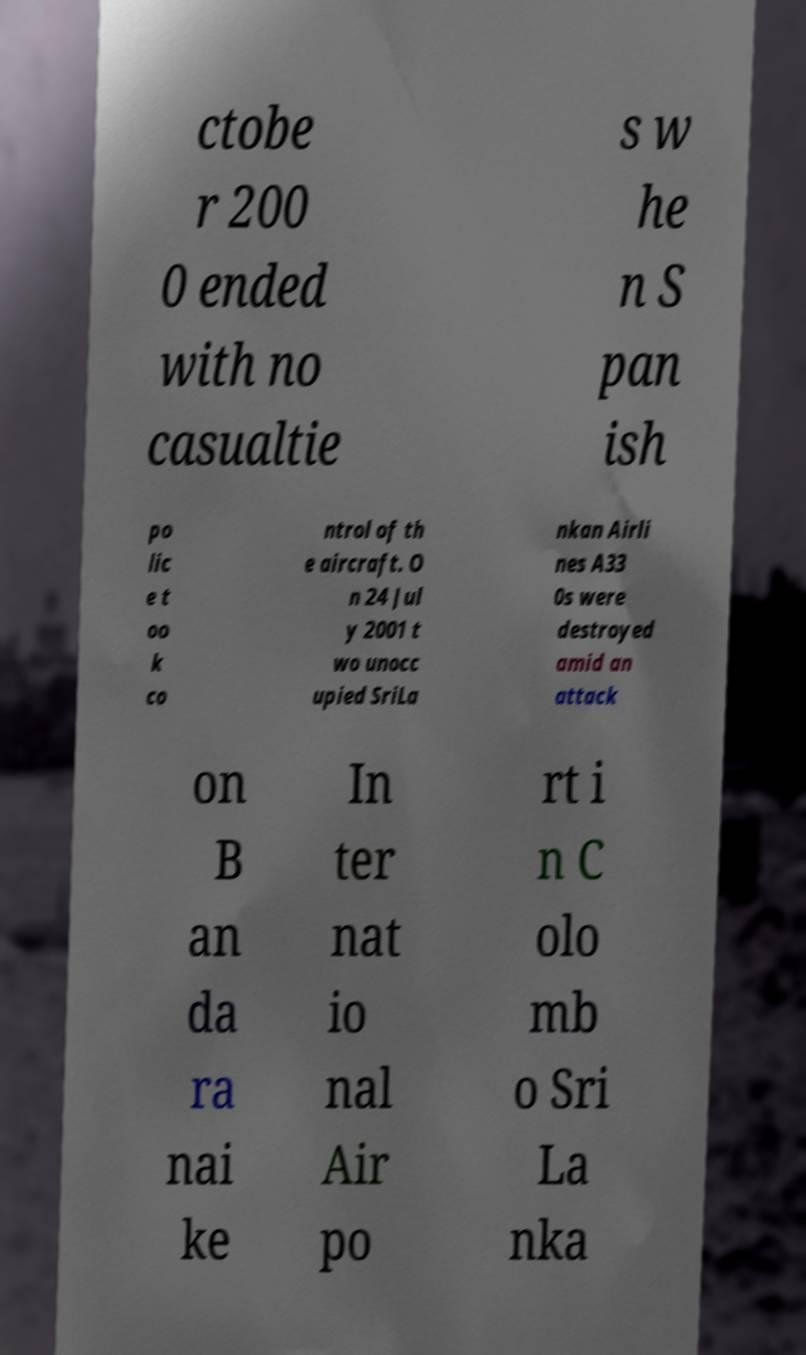Can you accurately transcribe the text from the provided image for me? ctobe r 200 0 ended with no casualtie s w he n S pan ish po lic e t oo k co ntrol of th e aircraft. O n 24 Jul y 2001 t wo unocc upied SriLa nkan Airli nes A33 0s were destroyed amid an attack on B an da ra nai ke In ter nat io nal Air po rt i n C olo mb o Sri La nka 